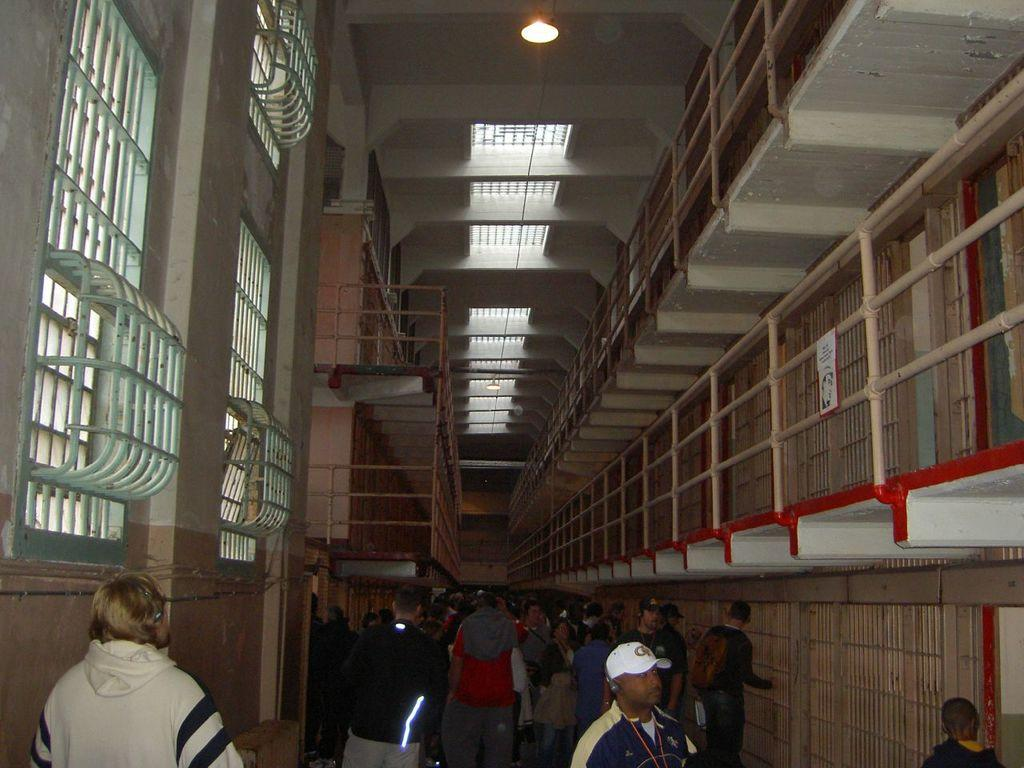Who or what can be seen in the image? There are people present in the image. What else is visible in the image besides the people? There is text, a person on a white surface, rods, and a light visible in the image. Can you see a seashore or an island in the image? No, there is no seashore or island present in the image. Is there a rake visible in the image? No, there is no rake present in the image. 